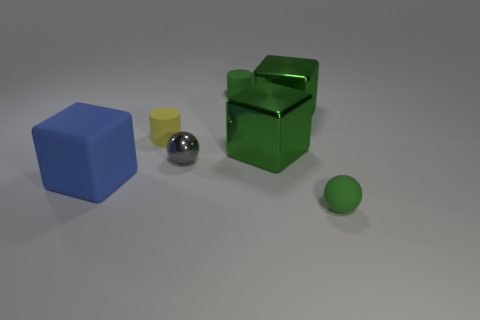Add 1 gray objects. How many objects exist? 8 Subtract all balls. How many objects are left? 5 Add 4 big metallic things. How many big metallic things are left? 6 Add 1 small brown metallic things. How many small brown metallic things exist? 1 Subtract 0 cyan cylinders. How many objects are left? 7 Subtract all brown rubber cylinders. Subtract all green spheres. How many objects are left? 6 